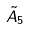Convert formula to latex. <formula><loc_0><loc_0><loc_500><loc_500>\tilde { A } _ { 5 }</formula> 